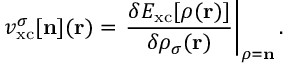Convert formula to latex. <formula><loc_0><loc_0><loc_500><loc_500>v _ { x c } ^ { \sigma } [ { n } ] ( { r } ) = \frac { \delta E _ { x c } [ { \boldsymbol \rho } ( { r } ) ] } { \delta \rho _ { \sigma } ( { r } ) } \right | _ { { \boldsymbol \rho } = { n } } .</formula> 